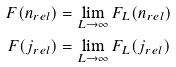Convert formula to latex. <formula><loc_0><loc_0><loc_500><loc_500>F ( n _ { r e l } ) & = \lim _ { L \to \infty } F _ { L } ( n _ { r e l } ) \\ F ( j _ { r e l } ) & = \lim _ { L \to \infty } F _ { L } ( j _ { r e l } )</formula> 